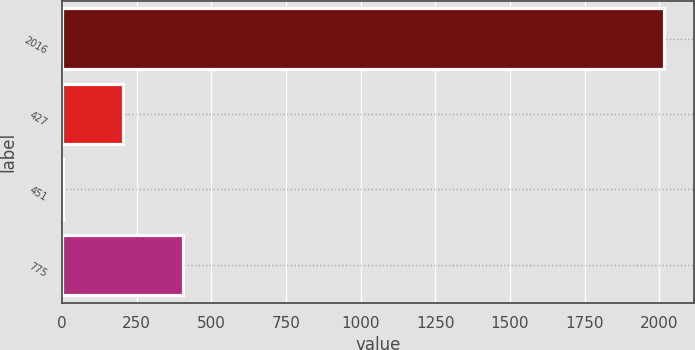<chart> <loc_0><loc_0><loc_500><loc_500><bar_chart><fcel>2016<fcel>427<fcel>451<fcel>775<nl><fcel>2015<fcel>205.17<fcel>4.08<fcel>406.26<nl></chart> 